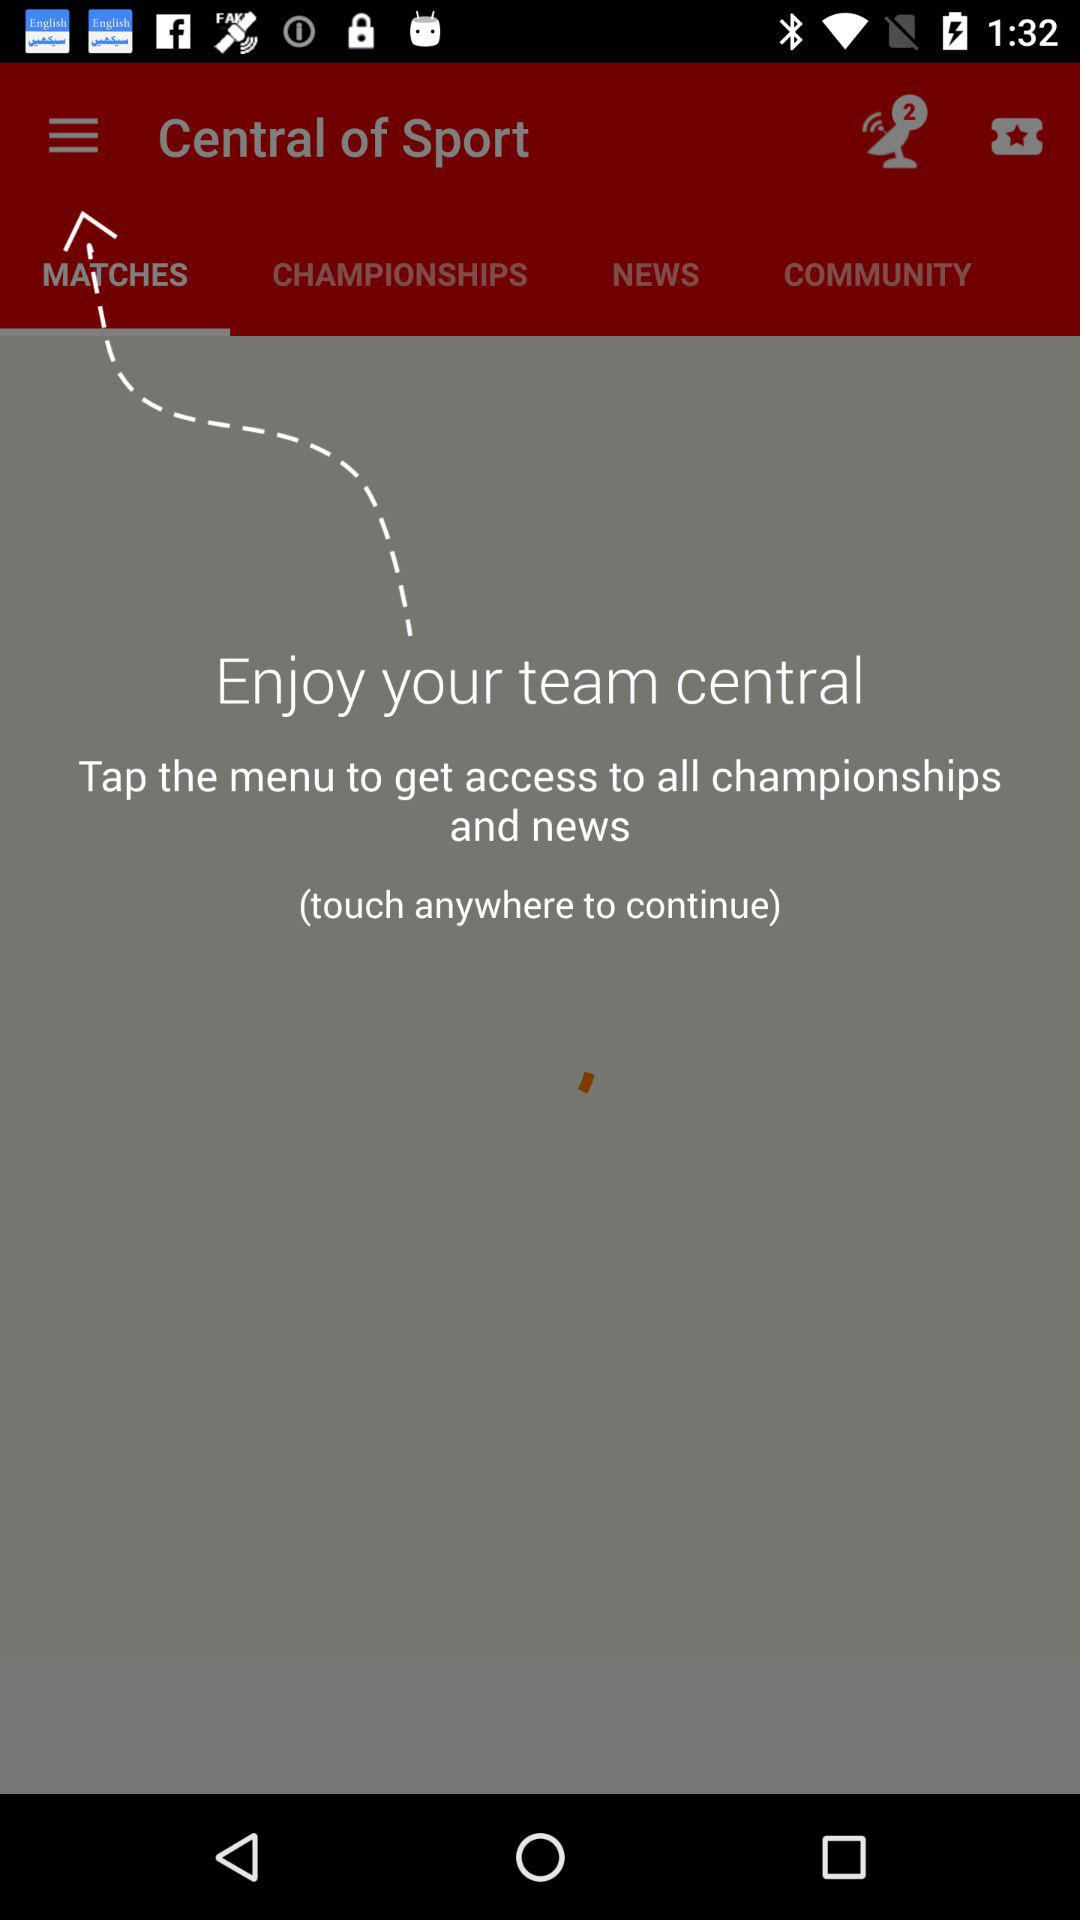Which button is to be tapped to get access to all championships and news? The button that is to be tapped to get access to all championships and news is menu. 